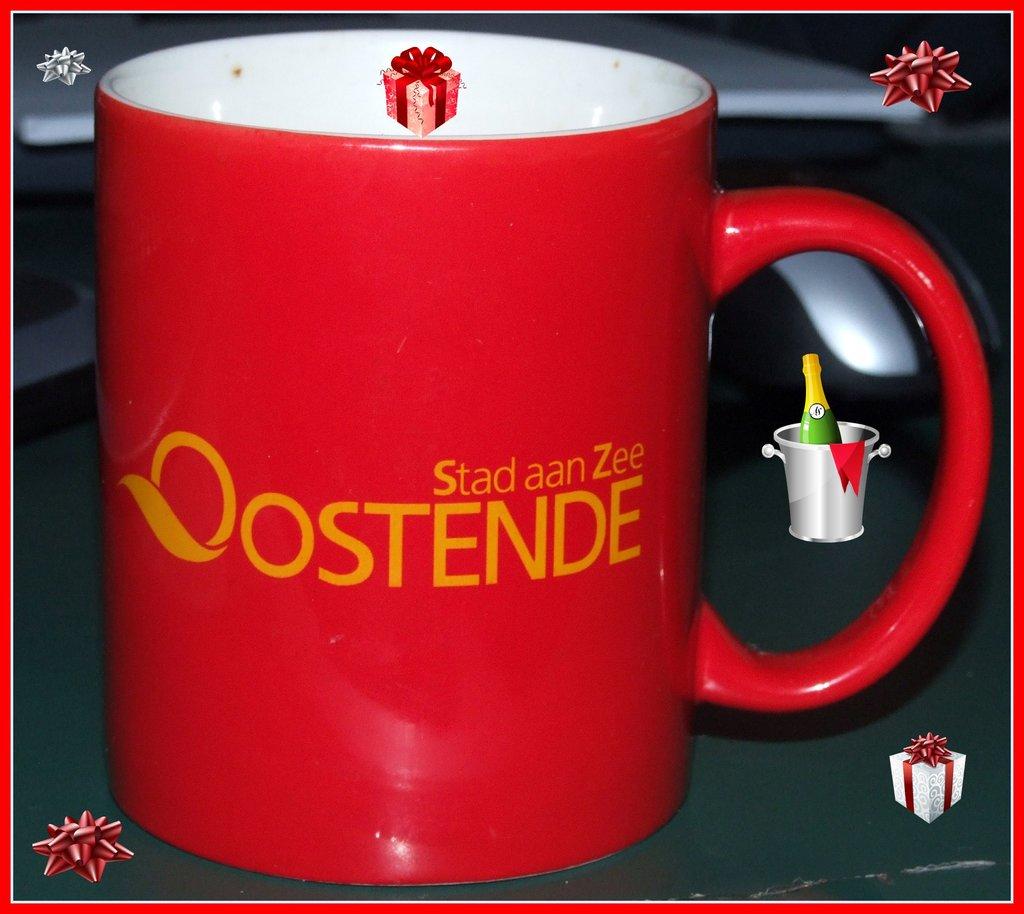Whats in small letters on the mug?
Offer a very short reply. Stad aan zee. What do the larger letter spell?
Your response must be concise. Oostende. 